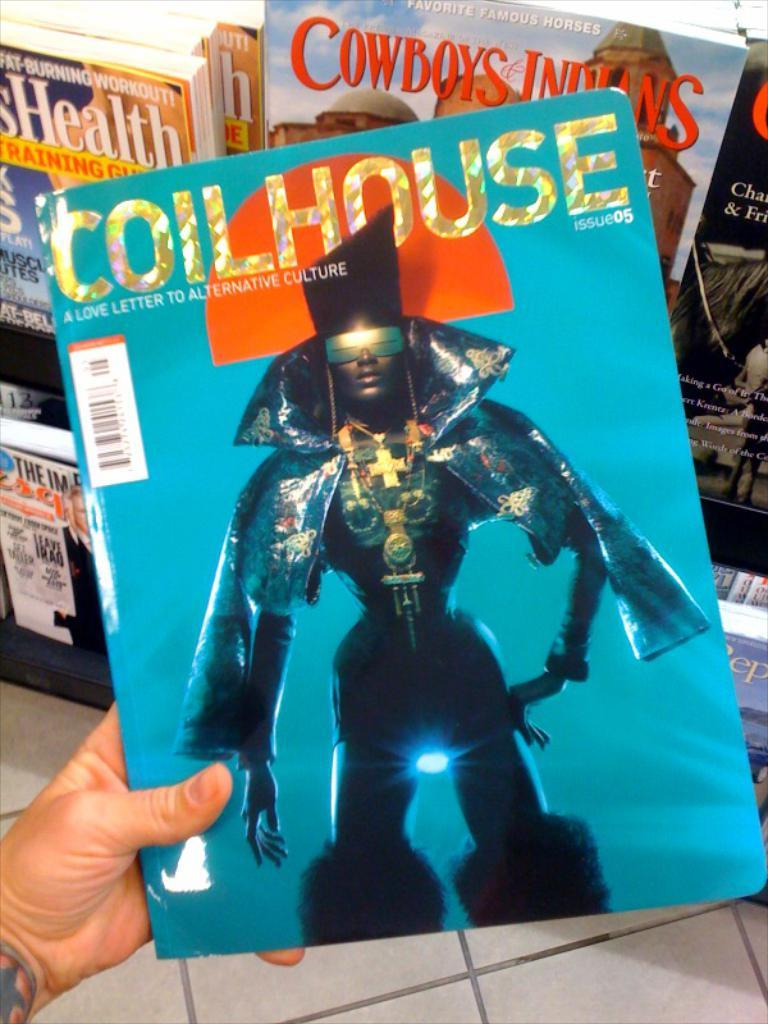Provide a one-sentence caption for the provided image. Someone is holding a magazine with the title Coilhouse. 